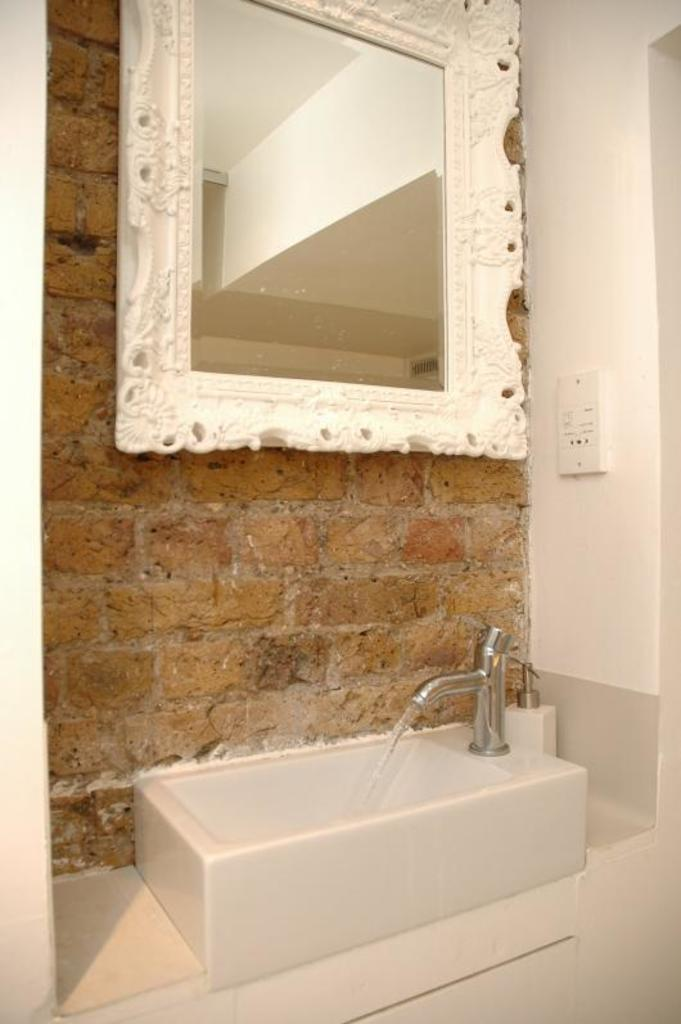What is attached to the wall in the image? There is a mirror on the wall in the image. What can be used for dispensing water in the image? There is a tap in the image. What is the tap connected to in the image? The tap is connected to a sink basin in the image. What type of coil is present in the image? There is no coil present in the image. What kind of apparatus is used for counting in the image? There is no apparatus for counting present in the image. 